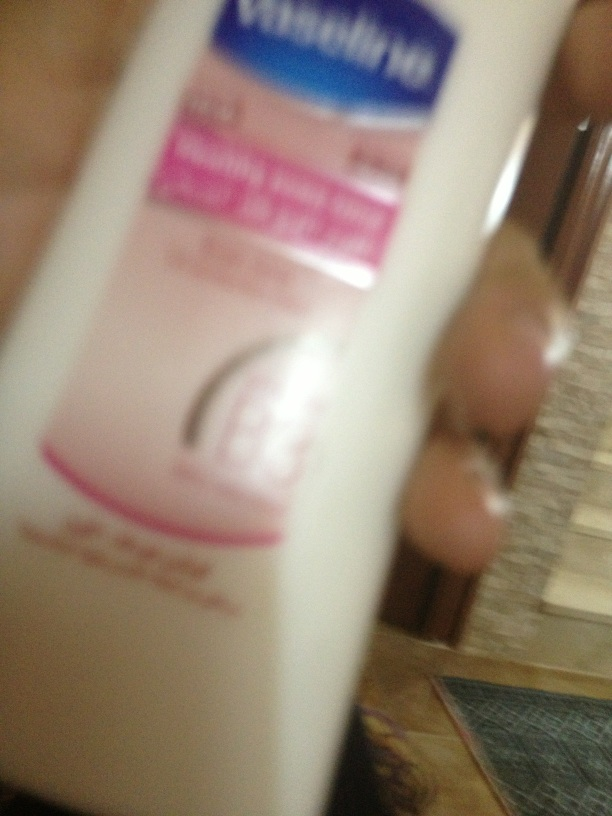Imagine this lotion had magical properties. What would those be? Imagine if this Vaseline lotion had the magical ability to not only moisturize the skin but also heal wounds instantly, protect against all skin ailments, and even provide a youthful glow that makes skin look decades younger. With just a drop, any cuts or bruises would vanish, returning the skin to its perfect state. Additionally, it could adapt to all skin types and conditions, providing exactly what each person needs to achieve their healthiest and most radiant skin. Perhaps it even glows softly, reflecting its magical properties, and emanates a calming scent that brings peace and relaxation to anyone who uses it. 